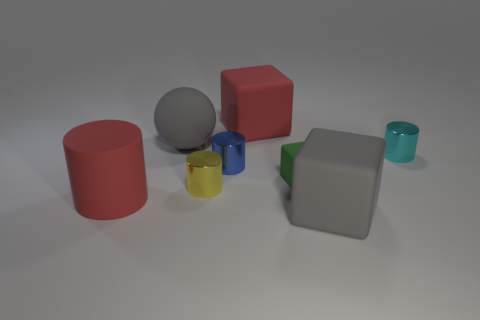Subtract 1 cylinders. How many cylinders are left? 3 Subtract all green cylinders. Subtract all purple cubes. How many cylinders are left? 4 Subtract all large rubber things. Subtract all tiny cyan metallic objects. How many objects are left? 3 Add 7 large spheres. How many large spheres are left? 8 Add 2 blue metal objects. How many blue metal objects exist? 3 Subtract 0 purple cylinders. How many objects are left? 8 Subtract all spheres. How many objects are left? 7 